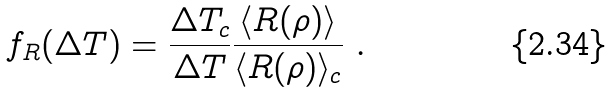Convert formula to latex. <formula><loc_0><loc_0><loc_500><loc_500>f _ { R } ( \Delta T ) = \frac { \Delta T _ { c } } { \Delta T } \frac { \langle R ( \rho ) \rangle } { \langle R ( \rho ) \rangle _ { c } } \ .</formula> 